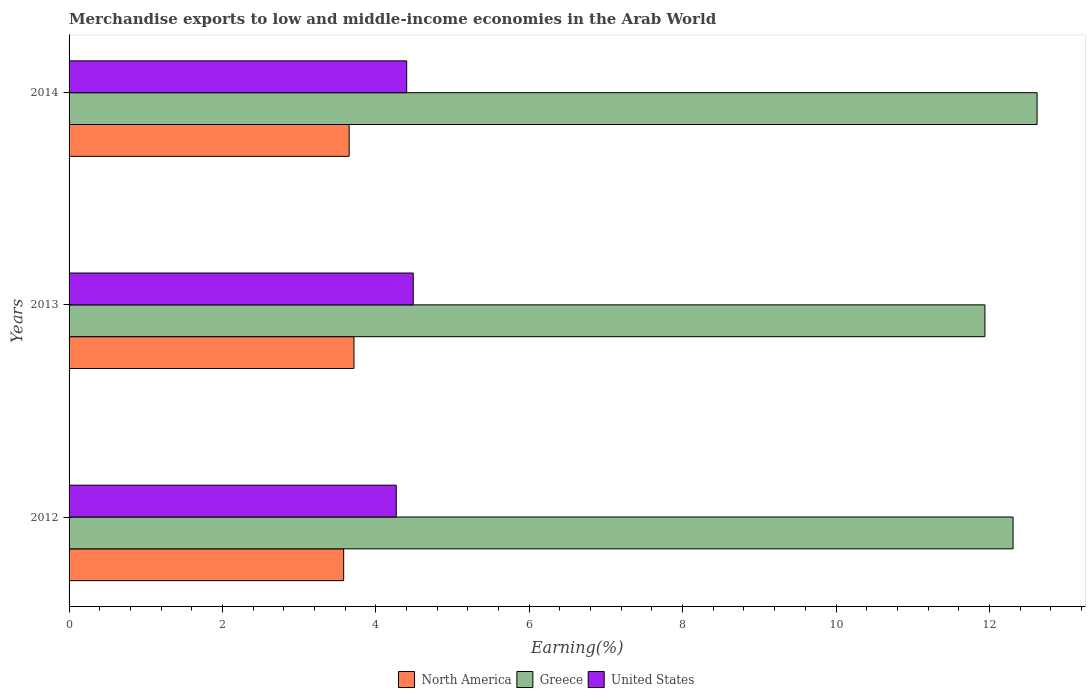How many different coloured bars are there?
Provide a succinct answer. 3. How many groups of bars are there?
Provide a succinct answer. 3. Are the number of bars per tick equal to the number of legend labels?
Keep it short and to the point. Yes. Are the number of bars on each tick of the Y-axis equal?
Your answer should be very brief. Yes. What is the percentage of amount earned from merchandise exports in North America in 2013?
Provide a succinct answer. 3.71. Across all years, what is the maximum percentage of amount earned from merchandise exports in United States?
Make the answer very short. 4.49. Across all years, what is the minimum percentage of amount earned from merchandise exports in Greece?
Make the answer very short. 11.94. What is the total percentage of amount earned from merchandise exports in United States in the graph?
Your response must be concise. 13.16. What is the difference between the percentage of amount earned from merchandise exports in North America in 2012 and that in 2014?
Offer a terse response. -0.07. What is the difference between the percentage of amount earned from merchandise exports in Greece in 2013 and the percentage of amount earned from merchandise exports in United States in 2012?
Provide a short and direct response. 7.68. What is the average percentage of amount earned from merchandise exports in Greece per year?
Your answer should be compact. 12.29. In the year 2012, what is the difference between the percentage of amount earned from merchandise exports in North America and percentage of amount earned from merchandise exports in United States?
Offer a terse response. -0.69. In how many years, is the percentage of amount earned from merchandise exports in United States greater than 12.4 %?
Keep it short and to the point. 0. What is the ratio of the percentage of amount earned from merchandise exports in North America in 2013 to that in 2014?
Give a very brief answer. 1.02. Is the percentage of amount earned from merchandise exports in United States in 2012 less than that in 2013?
Your answer should be compact. Yes. Is the difference between the percentage of amount earned from merchandise exports in North America in 2012 and 2013 greater than the difference between the percentage of amount earned from merchandise exports in United States in 2012 and 2013?
Your answer should be compact. Yes. What is the difference between the highest and the second highest percentage of amount earned from merchandise exports in United States?
Your answer should be very brief. 0.09. What is the difference between the highest and the lowest percentage of amount earned from merchandise exports in Greece?
Your response must be concise. 0.68. In how many years, is the percentage of amount earned from merchandise exports in Greece greater than the average percentage of amount earned from merchandise exports in Greece taken over all years?
Offer a very short reply. 2. Is the sum of the percentage of amount earned from merchandise exports in Greece in 2012 and 2014 greater than the maximum percentage of amount earned from merchandise exports in United States across all years?
Ensure brevity in your answer.  Yes. Is it the case that in every year, the sum of the percentage of amount earned from merchandise exports in Greece and percentage of amount earned from merchandise exports in North America is greater than the percentage of amount earned from merchandise exports in United States?
Offer a terse response. Yes. How many bars are there?
Your answer should be very brief. 9. Are all the bars in the graph horizontal?
Provide a succinct answer. Yes. How many years are there in the graph?
Your answer should be very brief. 3. What is the difference between two consecutive major ticks on the X-axis?
Offer a terse response. 2. Are the values on the major ticks of X-axis written in scientific E-notation?
Provide a succinct answer. No. How many legend labels are there?
Offer a very short reply. 3. How are the legend labels stacked?
Provide a succinct answer. Horizontal. What is the title of the graph?
Make the answer very short. Merchandise exports to low and middle-income economies in the Arab World. Does "Armenia" appear as one of the legend labels in the graph?
Offer a terse response. No. What is the label or title of the X-axis?
Keep it short and to the point. Earning(%). What is the label or title of the Y-axis?
Provide a short and direct response. Years. What is the Earning(%) in North America in 2012?
Provide a succinct answer. 3.58. What is the Earning(%) of Greece in 2012?
Offer a very short reply. 12.31. What is the Earning(%) of United States in 2012?
Your answer should be very brief. 4.27. What is the Earning(%) in North America in 2013?
Provide a short and direct response. 3.71. What is the Earning(%) in Greece in 2013?
Your response must be concise. 11.94. What is the Earning(%) of United States in 2013?
Provide a succinct answer. 4.49. What is the Earning(%) in North America in 2014?
Provide a short and direct response. 3.65. What is the Earning(%) in Greece in 2014?
Ensure brevity in your answer.  12.62. What is the Earning(%) in United States in 2014?
Your response must be concise. 4.4. Across all years, what is the maximum Earning(%) of North America?
Give a very brief answer. 3.71. Across all years, what is the maximum Earning(%) in Greece?
Give a very brief answer. 12.62. Across all years, what is the maximum Earning(%) of United States?
Provide a short and direct response. 4.49. Across all years, what is the minimum Earning(%) in North America?
Give a very brief answer. 3.58. Across all years, what is the minimum Earning(%) in Greece?
Give a very brief answer. 11.94. Across all years, what is the minimum Earning(%) of United States?
Your answer should be very brief. 4.27. What is the total Earning(%) in North America in the graph?
Provide a short and direct response. 10.95. What is the total Earning(%) in Greece in the graph?
Your answer should be very brief. 36.87. What is the total Earning(%) of United States in the graph?
Offer a very short reply. 13.16. What is the difference between the Earning(%) of North America in 2012 and that in 2013?
Your response must be concise. -0.13. What is the difference between the Earning(%) in Greece in 2012 and that in 2013?
Keep it short and to the point. 0.37. What is the difference between the Earning(%) of United States in 2012 and that in 2013?
Offer a terse response. -0.22. What is the difference between the Earning(%) in North America in 2012 and that in 2014?
Provide a short and direct response. -0.07. What is the difference between the Earning(%) in Greece in 2012 and that in 2014?
Your answer should be compact. -0.31. What is the difference between the Earning(%) of United States in 2012 and that in 2014?
Your answer should be very brief. -0.14. What is the difference between the Earning(%) in North America in 2013 and that in 2014?
Offer a very short reply. 0.06. What is the difference between the Earning(%) of Greece in 2013 and that in 2014?
Make the answer very short. -0.68. What is the difference between the Earning(%) of United States in 2013 and that in 2014?
Ensure brevity in your answer.  0.09. What is the difference between the Earning(%) in North America in 2012 and the Earning(%) in Greece in 2013?
Give a very brief answer. -8.36. What is the difference between the Earning(%) in North America in 2012 and the Earning(%) in United States in 2013?
Ensure brevity in your answer.  -0.91. What is the difference between the Earning(%) of Greece in 2012 and the Earning(%) of United States in 2013?
Provide a succinct answer. 7.82. What is the difference between the Earning(%) of North America in 2012 and the Earning(%) of Greece in 2014?
Make the answer very short. -9.04. What is the difference between the Earning(%) of North America in 2012 and the Earning(%) of United States in 2014?
Ensure brevity in your answer.  -0.82. What is the difference between the Earning(%) in Greece in 2012 and the Earning(%) in United States in 2014?
Ensure brevity in your answer.  7.91. What is the difference between the Earning(%) in North America in 2013 and the Earning(%) in Greece in 2014?
Give a very brief answer. -8.91. What is the difference between the Earning(%) in North America in 2013 and the Earning(%) in United States in 2014?
Make the answer very short. -0.69. What is the difference between the Earning(%) of Greece in 2013 and the Earning(%) of United States in 2014?
Your answer should be compact. 7.54. What is the average Earning(%) in North America per year?
Keep it short and to the point. 3.65. What is the average Earning(%) in Greece per year?
Offer a terse response. 12.29. What is the average Earning(%) of United States per year?
Your answer should be very brief. 4.39. In the year 2012, what is the difference between the Earning(%) in North America and Earning(%) in Greece?
Make the answer very short. -8.73. In the year 2012, what is the difference between the Earning(%) of North America and Earning(%) of United States?
Your answer should be very brief. -0.69. In the year 2012, what is the difference between the Earning(%) in Greece and Earning(%) in United States?
Offer a very short reply. 8.04. In the year 2013, what is the difference between the Earning(%) of North America and Earning(%) of Greece?
Make the answer very short. -8.23. In the year 2013, what is the difference between the Earning(%) of North America and Earning(%) of United States?
Give a very brief answer. -0.77. In the year 2013, what is the difference between the Earning(%) in Greece and Earning(%) in United States?
Your answer should be very brief. 7.45. In the year 2014, what is the difference between the Earning(%) in North America and Earning(%) in Greece?
Your response must be concise. -8.97. In the year 2014, what is the difference between the Earning(%) of North America and Earning(%) of United States?
Your answer should be very brief. -0.75. In the year 2014, what is the difference between the Earning(%) in Greece and Earning(%) in United States?
Your answer should be very brief. 8.22. What is the ratio of the Earning(%) of North America in 2012 to that in 2013?
Provide a short and direct response. 0.96. What is the ratio of the Earning(%) in Greece in 2012 to that in 2013?
Your answer should be compact. 1.03. What is the ratio of the Earning(%) of United States in 2012 to that in 2013?
Provide a succinct answer. 0.95. What is the ratio of the Earning(%) in North America in 2012 to that in 2014?
Your answer should be compact. 0.98. What is the ratio of the Earning(%) in Greece in 2012 to that in 2014?
Offer a very short reply. 0.98. What is the ratio of the Earning(%) in United States in 2012 to that in 2014?
Offer a terse response. 0.97. What is the ratio of the Earning(%) of North America in 2013 to that in 2014?
Your answer should be compact. 1.02. What is the ratio of the Earning(%) in Greece in 2013 to that in 2014?
Your answer should be very brief. 0.95. What is the ratio of the Earning(%) of United States in 2013 to that in 2014?
Ensure brevity in your answer.  1.02. What is the difference between the highest and the second highest Earning(%) of North America?
Provide a succinct answer. 0.06. What is the difference between the highest and the second highest Earning(%) in Greece?
Provide a succinct answer. 0.31. What is the difference between the highest and the second highest Earning(%) of United States?
Provide a short and direct response. 0.09. What is the difference between the highest and the lowest Earning(%) in North America?
Offer a very short reply. 0.13. What is the difference between the highest and the lowest Earning(%) in Greece?
Give a very brief answer. 0.68. What is the difference between the highest and the lowest Earning(%) of United States?
Provide a succinct answer. 0.22. 